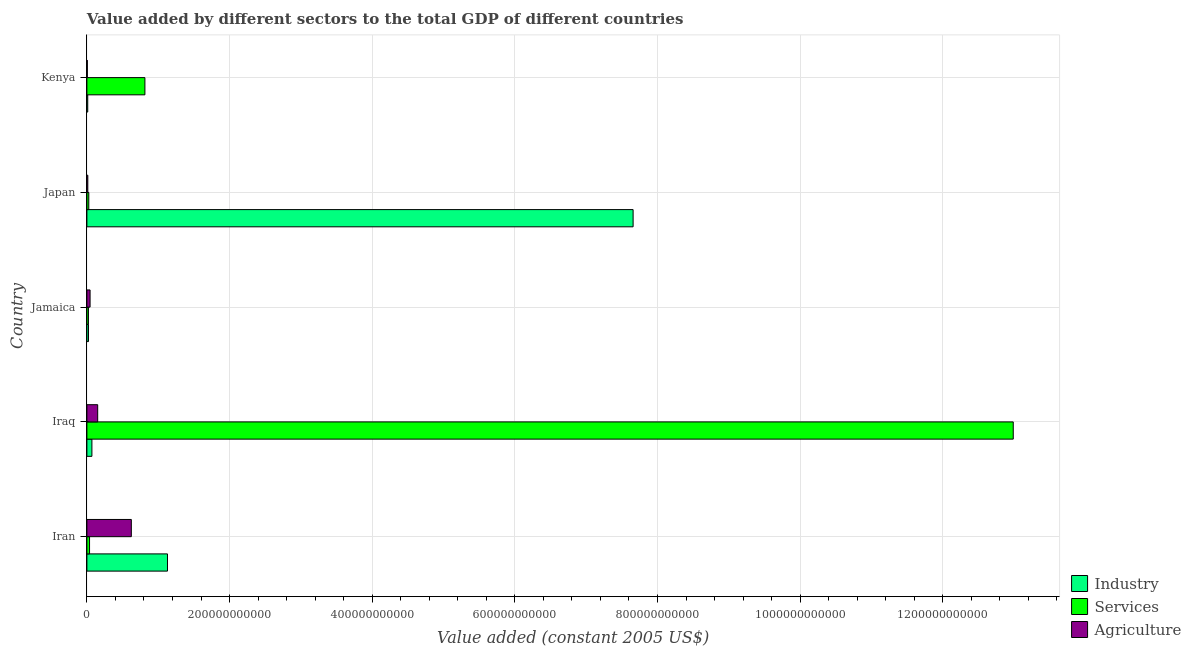How many different coloured bars are there?
Your response must be concise. 3. Are the number of bars per tick equal to the number of legend labels?
Keep it short and to the point. Yes. Are the number of bars on each tick of the Y-axis equal?
Your response must be concise. Yes. What is the value added by agricultural sector in Japan?
Keep it short and to the point. 1.29e+09. Across all countries, what is the maximum value added by agricultural sector?
Give a very brief answer. 6.23e+1. Across all countries, what is the minimum value added by services?
Your answer should be compact. 2.18e+09. In which country was the value added by industrial sector minimum?
Your answer should be very brief. Kenya. What is the total value added by industrial sector in the graph?
Offer a very short reply. 8.89e+11. What is the difference between the value added by industrial sector in Iraq and that in Kenya?
Offer a terse response. 5.85e+09. What is the difference between the value added by industrial sector in Iran and the value added by agricultural sector in Iraq?
Keep it short and to the point. 9.79e+1. What is the average value added by industrial sector per country?
Provide a short and direct response. 1.78e+11. What is the difference between the value added by industrial sector and value added by agricultural sector in Iraq?
Your answer should be compact. -8.10e+09. In how many countries, is the value added by agricultural sector greater than 1240000000000 US$?
Provide a succinct answer. 0. What is the ratio of the value added by agricultural sector in Iran to that in Iraq?
Provide a short and direct response. 4.12. Is the value added by services in Iraq less than that in Japan?
Keep it short and to the point. No. What is the difference between the highest and the second highest value added by agricultural sector?
Make the answer very short. 4.72e+1. What is the difference between the highest and the lowest value added by agricultural sector?
Offer a terse response. 6.17e+1. Is the sum of the value added by services in Iran and Jamaica greater than the maximum value added by agricultural sector across all countries?
Offer a terse response. No. What does the 1st bar from the top in Kenya represents?
Ensure brevity in your answer.  Agriculture. What does the 3rd bar from the bottom in Jamaica represents?
Make the answer very short. Agriculture. Is it the case that in every country, the sum of the value added by industrial sector and value added by services is greater than the value added by agricultural sector?
Your answer should be compact. No. How many countries are there in the graph?
Ensure brevity in your answer.  5. What is the difference between two consecutive major ticks on the X-axis?
Provide a succinct answer. 2.00e+11. Does the graph contain any zero values?
Keep it short and to the point. No. Where does the legend appear in the graph?
Offer a very short reply. Bottom right. How are the legend labels stacked?
Provide a succinct answer. Vertical. What is the title of the graph?
Your answer should be very brief. Value added by different sectors to the total GDP of different countries. Does "Natural Gas" appear as one of the legend labels in the graph?
Your response must be concise. No. What is the label or title of the X-axis?
Make the answer very short. Value added (constant 2005 US$). What is the Value added (constant 2005 US$) in Industry in Iran?
Give a very brief answer. 1.13e+11. What is the Value added (constant 2005 US$) of Services in Iran?
Ensure brevity in your answer.  3.72e+09. What is the Value added (constant 2005 US$) in Agriculture in Iran?
Offer a terse response. 6.23e+1. What is the Value added (constant 2005 US$) of Industry in Iraq?
Your answer should be very brief. 7.02e+09. What is the Value added (constant 2005 US$) in Services in Iraq?
Your answer should be compact. 1.30e+12. What is the Value added (constant 2005 US$) in Agriculture in Iraq?
Your response must be concise. 1.51e+1. What is the Value added (constant 2005 US$) of Industry in Jamaica?
Offer a very short reply. 2.26e+09. What is the Value added (constant 2005 US$) in Services in Jamaica?
Your answer should be very brief. 2.18e+09. What is the Value added (constant 2005 US$) in Agriculture in Jamaica?
Your response must be concise. 4.47e+09. What is the Value added (constant 2005 US$) of Industry in Japan?
Make the answer very short. 7.66e+11. What is the Value added (constant 2005 US$) of Services in Japan?
Offer a very short reply. 2.68e+09. What is the Value added (constant 2005 US$) of Agriculture in Japan?
Provide a succinct answer. 1.29e+09. What is the Value added (constant 2005 US$) of Industry in Kenya?
Offer a very short reply. 1.17e+09. What is the Value added (constant 2005 US$) in Services in Kenya?
Keep it short and to the point. 8.13e+1. What is the Value added (constant 2005 US$) of Agriculture in Kenya?
Provide a short and direct response. 6.22e+08. Across all countries, what is the maximum Value added (constant 2005 US$) in Industry?
Give a very brief answer. 7.66e+11. Across all countries, what is the maximum Value added (constant 2005 US$) in Services?
Ensure brevity in your answer.  1.30e+12. Across all countries, what is the maximum Value added (constant 2005 US$) in Agriculture?
Give a very brief answer. 6.23e+1. Across all countries, what is the minimum Value added (constant 2005 US$) of Industry?
Your answer should be very brief. 1.17e+09. Across all countries, what is the minimum Value added (constant 2005 US$) of Services?
Provide a short and direct response. 2.18e+09. Across all countries, what is the minimum Value added (constant 2005 US$) in Agriculture?
Provide a succinct answer. 6.22e+08. What is the total Value added (constant 2005 US$) of Industry in the graph?
Offer a very short reply. 8.89e+11. What is the total Value added (constant 2005 US$) of Services in the graph?
Give a very brief answer. 1.39e+12. What is the total Value added (constant 2005 US$) of Agriculture in the graph?
Keep it short and to the point. 8.38e+1. What is the difference between the Value added (constant 2005 US$) in Industry in Iran and that in Iraq?
Provide a succinct answer. 1.06e+11. What is the difference between the Value added (constant 2005 US$) in Services in Iran and that in Iraq?
Make the answer very short. -1.30e+12. What is the difference between the Value added (constant 2005 US$) of Agriculture in Iran and that in Iraq?
Ensure brevity in your answer.  4.72e+1. What is the difference between the Value added (constant 2005 US$) of Industry in Iran and that in Jamaica?
Your answer should be compact. 1.11e+11. What is the difference between the Value added (constant 2005 US$) of Services in Iran and that in Jamaica?
Offer a very short reply. 1.54e+09. What is the difference between the Value added (constant 2005 US$) of Agriculture in Iran and that in Jamaica?
Make the answer very short. 5.78e+1. What is the difference between the Value added (constant 2005 US$) of Industry in Iran and that in Japan?
Keep it short and to the point. -6.53e+11. What is the difference between the Value added (constant 2005 US$) in Services in Iran and that in Japan?
Your answer should be very brief. 1.04e+09. What is the difference between the Value added (constant 2005 US$) in Agriculture in Iran and that in Japan?
Your response must be concise. 6.10e+1. What is the difference between the Value added (constant 2005 US$) in Industry in Iran and that in Kenya?
Provide a short and direct response. 1.12e+11. What is the difference between the Value added (constant 2005 US$) in Services in Iran and that in Kenya?
Offer a very short reply. -7.76e+1. What is the difference between the Value added (constant 2005 US$) of Agriculture in Iran and that in Kenya?
Offer a very short reply. 6.17e+1. What is the difference between the Value added (constant 2005 US$) of Industry in Iraq and that in Jamaica?
Give a very brief answer. 4.76e+09. What is the difference between the Value added (constant 2005 US$) in Services in Iraq and that in Jamaica?
Offer a very short reply. 1.30e+12. What is the difference between the Value added (constant 2005 US$) of Agriculture in Iraq and that in Jamaica?
Provide a succinct answer. 1.07e+1. What is the difference between the Value added (constant 2005 US$) in Industry in Iraq and that in Japan?
Provide a succinct answer. -7.59e+11. What is the difference between the Value added (constant 2005 US$) of Services in Iraq and that in Japan?
Ensure brevity in your answer.  1.30e+12. What is the difference between the Value added (constant 2005 US$) of Agriculture in Iraq and that in Japan?
Your answer should be very brief. 1.38e+1. What is the difference between the Value added (constant 2005 US$) in Industry in Iraq and that in Kenya?
Your response must be concise. 5.85e+09. What is the difference between the Value added (constant 2005 US$) in Services in Iraq and that in Kenya?
Keep it short and to the point. 1.22e+12. What is the difference between the Value added (constant 2005 US$) in Agriculture in Iraq and that in Kenya?
Ensure brevity in your answer.  1.45e+1. What is the difference between the Value added (constant 2005 US$) in Industry in Jamaica and that in Japan?
Offer a very short reply. -7.64e+11. What is the difference between the Value added (constant 2005 US$) of Services in Jamaica and that in Japan?
Provide a short and direct response. -4.92e+08. What is the difference between the Value added (constant 2005 US$) in Agriculture in Jamaica and that in Japan?
Give a very brief answer. 3.18e+09. What is the difference between the Value added (constant 2005 US$) of Industry in Jamaica and that in Kenya?
Your answer should be compact. 1.08e+09. What is the difference between the Value added (constant 2005 US$) of Services in Jamaica and that in Kenya?
Make the answer very short. -7.92e+1. What is the difference between the Value added (constant 2005 US$) in Agriculture in Jamaica and that in Kenya?
Make the answer very short. 3.84e+09. What is the difference between the Value added (constant 2005 US$) in Industry in Japan and that in Kenya?
Ensure brevity in your answer.  7.65e+11. What is the difference between the Value added (constant 2005 US$) in Services in Japan and that in Kenya?
Your answer should be compact. -7.87e+1. What is the difference between the Value added (constant 2005 US$) of Agriculture in Japan and that in Kenya?
Provide a short and direct response. 6.65e+08. What is the difference between the Value added (constant 2005 US$) of Industry in Iran and the Value added (constant 2005 US$) of Services in Iraq?
Keep it short and to the point. -1.19e+12. What is the difference between the Value added (constant 2005 US$) of Industry in Iran and the Value added (constant 2005 US$) of Agriculture in Iraq?
Give a very brief answer. 9.79e+1. What is the difference between the Value added (constant 2005 US$) in Services in Iran and the Value added (constant 2005 US$) in Agriculture in Iraq?
Make the answer very short. -1.14e+1. What is the difference between the Value added (constant 2005 US$) of Industry in Iran and the Value added (constant 2005 US$) of Services in Jamaica?
Offer a very short reply. 1.11e+11. What is the difference between the Value added (constant 2005 US$) of Industry in Iran and the Value added (constant 2005 US$) of Agriculture in Jamaica?
Your answer should be compact. 1.09e+11. What is the difference between the Value added (constant 2005 US$) of Services in Iran and the Value added (constant 2005 US$) of Agriculture in Jamaica?
Your answer should be compact. -7.46e+08. What is the difference between the Value added (constant 2005 US$) in Industry in Iran and the Value added (constant 2005 US$) in Services in Japan?
Your answer should be compact. 1.10e+11. What is the difference between the Value added (constant 2005 US$) of Industry in Iran and the Value added (constant 2005 US$) of Agriculture in Japan?
Offer a terse response. 1.12e+11. What is the difference between the Value added (constant 2005 US$) of Services in Iran and the Value added (constant 2005 US$) of Agriculture in Japan?
Provide a short and direct response. 2.43e+09. What is the difference between the Value added (constant 2005 US$) in Industry in Iran and the Value added (constant 2005 US$) in Services in Kenya?
Provide a short and direct response. 3.16e+1. What is the difference between the Value added (constant 2005 US$) of Industry in Iran and the Value added (constant 2005 US$) of Agriculture in Kenya?
Offer a terse response. 1.12e+11. What is the difference between the Value added (constant 2005 US$) in Services in Iran and the Value added (constant 2005 US$) in Agriculture in Kenya?
Provide a succinct answer. 3.10e+09. What is the difference between the Value added (constant 2005 US$) of Industry in Iraq and the Value added (constant 2005 US$) of Services in Jamaica?
Provide a short and direct response. 4.84e+09. What is the difference between the Value added (constant 2005 US$) in Industry in Iraq and the Value added (constant 2005 US$) in Agriculture in Jamaica?
Ensure brevity in your answer.  2.55e+09. What is the difference between the Value added (constant 2005 US$) of Services in Iraq and the Value added (constant 2005 US$) of Agriculture in Jamaica?
Offer a terse response. 1.29e+12. What is the difference between the Value added (constant 2005 US$) in Industry in Iraq and the Value added (constant 2005 US$) in Services in Japan?
Give a very brief answer. 4.34e+09. What is the difference between the Value added (constant 2005 US$) of Industry in Iraq and the Value added (constant 2005 US$) of Agriculture in Japan?
Offer a terse response. 5.73e+09. What is the difference between the Value added (constant 2005 US$) in Services in Iraq and the Value added (constant 2005 US$) in Agriculture in Japan?
Make the answer very short. 1.30e+12. What is the difference between the Value added (constant 2005 US$) in Industry in Iraq and the Value added (constant 2005 US$) in Services in Kenya?
Your answer should be compact. -7.43e+1. What is the difference between the Value added (constant 2005 US$) of Industry in Iraq and the Value added (constant 2005 US$) of Agriculture in Kenya?
Offer a terse response. 6.40e+09. What is the difference between the Value added (constant 2005 US$) in Services in Iraq and the Value added (constant 2005 US$) in Agriculture in Kenya?
Make the answer very short. 1.30e+12. What is the difference between the Value added (constant 2005 US$) in Industry in Jamaica and the Value added (constant 2005 US$) in Services in Japan?
Ensure brevity in your answer.  -4.20e+08. What is the difference between the Value added (constant 2005 US$) of Industry in Jamaica and the Value added (constant 2005 US$) of Agriculture in Japan?
Provide a short and direct response. 9.69e+08. What is the difference between the Value added (constant 2005 US$) in Services in Jamaica and the Value added (constant 2005 US$) in Agriculture in Japan?
Offer a terse response. 8.97e+08. What is the difference between the Value added (constant 2005 US$) in Industry in Jamaica and the Value added (constant 2005 US$) in Services in Kenya?
Your answer should be very brief. -7.91e+1. What is the difference between the Value added (constant 2005 US$) of Industry in Jamaica and the Value added (constant 2005 US$) of Agriculture in Kenya?
Your answer should be compact. 1.63e+09. What is the difference between the Value added (constant 2005 US$) in Services in Jamaica and the Value added (constant 2005 US$) in Agriculture in Kenya?
Ensure brevity in your answer.  1.56e+09. What is the difference between the Value added (constant 2005 US$) of Industry in Japan and the Value added (constant 2005 US$) of Services in Kenya?
Give a very brief answer. 6.84e+11. What is the difference between the Value added (constant 2005 US$) of Industry in Japan and the Value added (constant 2005 US$) of Agriculture in Kenya?
Keep it short and to the point. 7.65e+11. What is the difference between the Value added (constant 2005 US$) of Services in Japan and the Value added (constant 2005 US$) of Agriculture in Kenya?
Give a very brief answer. 2.05e+09. What is the average Value added (constant 2005 US$) in Industry per country?
Give a very brief answer. 1.78e+11. What is the average Value added (constant 2005 US$) of Services per country?
Your answer should be very brief. 2.78e+11. What is the average Value added (constant 2005 US$) of Agriculture per country?
Ensure brevity in your answer.  1.68e+1. What is the difference between the Value added (constant 2005 US$) of Industry and Value added (constant 2005 US$) of Services in Iran?
Make the answer very short. 1.09e+11. What is the difference between the Value added (constant 2005 US$) in Industry and Value added (constant 2005 US$) in Agriculture in Iran?
Your answer should be compact. 5.07e+1. What is the difference between the Value added (constant 2005 US$) in Services and Value added (constant 2005 US$) in Agriculture in Iran?
Ensure brevity in your answer.  -5.86e+1. What is the difference between the Value added (constant 2005 US$) in Industry and Value added (constant 2005 US$) in Services in Iraq?
Keep it short and to the point. -1.29e+12. What is the difference between the Value added (constant 2005 US$) of Industry and Value added (constant 2005 US$) of Agriculture in Iraq?
Offer a terse response. -8.10e+09. What is the difference between the Value added (constant 2005 US$) of Services and Value added (constant 2005 US$) of Agriculture in Iraq?
Offer a terse response. 1.28e+12. What is the difference between the Value added (constant 2005 US$) in Industry and Value added (constant 2005 US$) in Services in Jamaica?
Ensure brevity in your answer.  7.15e+07. What is the difference between the Value added (constant 2005 US$) of Industry and Value added (constant 2005 US$) of Agriculture in Jamaica?
Ensure brevity in your answer.  -2.21e+09. What is the difference between the Value added (constant 2005 US$) in Services and Value added (constant 2005 US$) in Agriculture in Jamaica?
Make the answer very short. -2.28e+09. What is the difference between the Value added (constant 2005 US$) in Industry and Value added (constant 2005 US$) in Services in Japan?
Provide a succinct answer. 7.63e+11. What is the difference between the Value added (constant 2005 US$) of Industry and Value added (constant 2005 US$) of Agriculture in Japan?
Keep it short and to the point. 7.65e+11. What is the difference between the Value added (constant 2005 US$) in Services and Value added (constant 2005 US$) in Agriculture in Japan?
Give a very brief answer. 1.39e+09. What is the difference between the Value added (constant 2005 US$) in Industry and Value added (constant 2005 US$) in Services in Kenya?
Provide a short and direct response. -8.02e+1. What is the difference between the Value added (constant 2005 US$) of Industry and Value added (constant 2005 US$) of Agriculture in Kenya?
Make the answer very short. 5.51e+08. What is the difference between the Value added (constant 2005 US$) of Services and Value added (constant 2005 US$) of Agriculture in Kenya?
Your answer should be compact. 8.07e+1. What is the ratio of the Value added (constant 2005 US$) of Industry in Iran to that in Iraq?
Keep it short and to the point. 16.1. What is the ratio of the Value added (constant 2005 US$) in Services in Iran to that in Iraq?
Offer a very short reply. 0. What is the ratio of the Value added (constant 2005 US$) in Agriculture in Iran to that in Iraq?
Your answer should be compact. 4.12. What is the ratio of the Value added (constant 2005 US$) of Industry in Iran to that in Jamaica?
Offer a very short reply. 50.08. What is the ratio of the Value added (constant 2005 US$) of Services in Iran to that in Jamaica?
Your answer should be very brief. 1.7. What is the ratio of the Value added (constant 2005 US$) of Agriculture in Iran to that in Jamaica?
Your response must be concise. 13.95. What is the ratio of the Value added (constant 2005 US$) of Industry in Iran to that in Japan?
Offer a terse response. 0.15. What is the ratio of the Value added (constant 2005 US$) of Services in Iran to that in Japan?
Make the answer very short. 1.39. What is the ratio of the Value added (constant 2005 US$) in Agriculture in Iran to that in Japan?
Provide a short and direct response. 48.39. What is the ratio of the Value added (constant 2005 US$) in Industry in Iran to that in Kenya?
Make the answer very short. 96.3. What is the ratio of the Value added (constant 2005 US$) of Services in Iran to that in Kenya?
Make the answer very short. 0.05. What is the ratio of the Value added (constant 2005 US$) of Agriculture in Iran to that in Kenya?
Provide a short and direct response. 100.11. What is the ratio of the Value added (constant 2005 US$) of Industry in Iraq to that in Jamaica?
Your response must be concise. 3.11. What is the ratio of the Value added (constant 2005 US$) of Services in Iraq to that in Jamaica?
Keep it short and to the point. 594.54. What is the ratio of the Value added (constant 2005 US$) of Agriculture in Iraq to that in Jamaica?
Your answer should be compact. 3.39. What is the ratio of the Value added (constant 2005 US$) in Industry in Iraq to that in Japan?
Your answer should be compact. 0.01. What is the ratio of the Value added (constant 2005 US$) in Services in Iraq to that in Japan?
Your answer should be very brief. 485.34. What is the ratio of the Value added (constant 2005 US$) in Agriculture in Iraq to that in Japan?
Your answer should be very brief. 11.75. What is the ratio of the Value added (constant 2005 US$) of Industry in Iraq to that in Kenya?
Your answer should be compact. 5.98. What is the ratio of the Value added (constant 2005 US$) in Services in Iraq to that in Kenya?
Ensure brevity in your answer.  15.97. What is the ratio of the Value added (constant 2005 US$) of Agriculture in Iraq to that in Kenya?
Your answer should be compact. 24.3. What is the ratio of the Value added (constant 2005 US$) in Industry in Jamaica to that in Japan?
Ensure brevity in your answer.  0. What is the ratio of the Value added (constant 2005 US$) in Services in Jamaica to that in Japan?
Provide a succinct answer. 0.82. What is the ratio of the Value added (constant 2005 US$) in Agriculture in Jamaica to that in Japan?
Your response must be concise. 3.47. What is the ratio of the Value added (constant 2005 US$) in Industry in Jamaica to that in Kenya?
Offer a terse response. 1.92. What is the ratio of the Value added (constant 2005 US$) of Services in Jamaica to that in Kenya?
Provide a short and direct response. 0.03. What is the ratio of the Value added (constant 2005 US$) in Agriculture in Jamaica to that in Kenya?
Make the answer very short. 7.18. What is the ratio of the Value added (constant 2005 US$) in Industry in Japan to that in Kenya?
Your answer should be compact. 652.71. What is the ratio of the Value added (constant 2005 US$) of Services in Japan to that in Kenya?
Provide a succinct answer. 0.03. What is the ratio of the Value added (constant 2005 US$) in Agriculture in Japan to that in Kenya?
Your answer should be compact. 2.07. What is the difference between the highest and the second highest Value added (constant 2005 US$) of Industry?
Provide a succinct answer. 6.53e+11. What is the difference between the highest and the second highest Value added (constant 2005 US$) in Services?
Make the answer very short. 1.22e+12. What is the difference between the highest and the second highest Value added (constant 2005 US$) in Agriculture?
Offer a very short reply. 4.72e+1. What is the difference between the highest and the lowest Value added (constant 2005 US$) in Industry?
Provide a short and direct response. 7.65e+11. What is the difference between the highest and the lowest Value added (constant 2005 US$) in Services?
Offer a very short reply. 1.30e+12. What is the difference between the highest and the lowest Value added (constant 2005 US$) in Agriculture?
Offer a very short reply. 6.17e+1. 